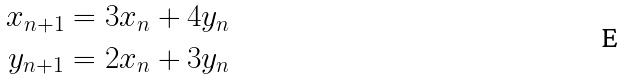Convert formula to latex. <formula><loc_0><loc_0><loc_500><loc_500>x _ { n + 1 } & = 3 x _ { n } + 4 y _ { n } \\ y _ { n + 1 } & = 2 x _ { n } + 3 y _ { n }</formula> 